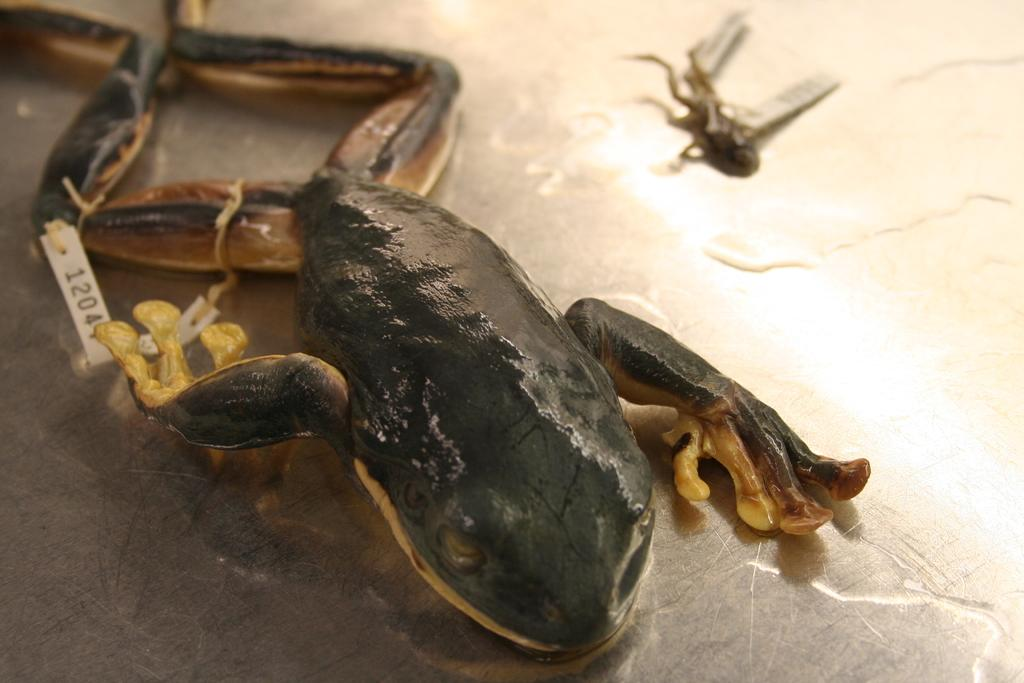What type of animal is in the image? There is a reptile in the image. Can you describe the reptile's location in the image? The reptile is in the water in the image. Is there any additional information about the reptile? Yes, the reptile has a tag in the image. What type of plough is being used by the government in the image? There is no plough or government presence in the image; it features a reptile in the water with a tag. 